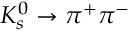Convert formula to latex. <formula><loc_0><loc_0><loc_500><loc_500>K _ { s } ^ { 0 } \rightarrow \pi ^ { + } \pi ^ { - }</formula> 